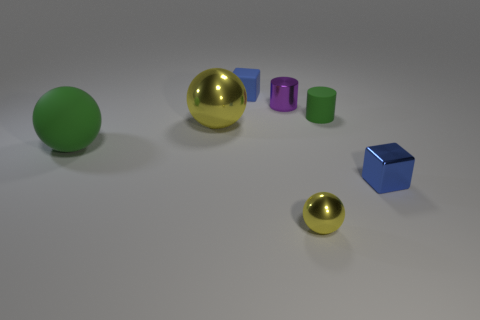What could be the purpose of this arrangement of objects? This arrangement of objects might serve several purposes. It could be an artistic composition designed to showcase contrasts in color, shape, and material. Alternatively, it may represent a 3D render testing scene, commonly used for evaluating the rendering capabilities of software in terms of light, shadow, and material visualization. How so? In a render test, objects with different geometries and materials are used to evaluate how well a rendering engine can simulate surfaces, reflections, and interactions with light. Such tests help in fine-tuning the visual output of the software for more accurate and realistic simulations. 